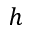Convert formula to latex. <formula><loc_0><loc_0><loc_500><loc_500>h</formula> 